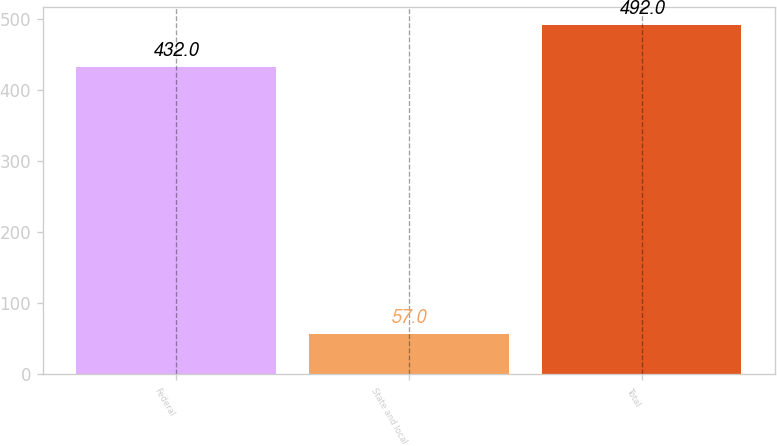Convert chart. <chart><loc_0><loc_0><loc_500><loc_500><bar_chart><fcel>Federal<fcel>State and local<fcel>Total<nl><fcel>432<fcel>57<fcel>492<nl></chart> 